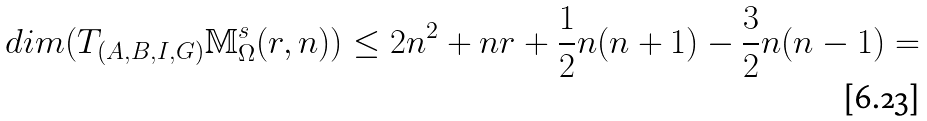<formula> <loc_0><loc_0><loc_500><loc_500>d i m ( T _ { ( A , B , I , G ) } \mathbb { M } _ { \Omega } ^ { s } ( r , n ) ) \leq 2 n ^ { 2 } + n r + \frac { 1 } { 2 } n ( n + 1 ) - \frac { 3 } { 2 } n ( n - 1 ) =</formula> 